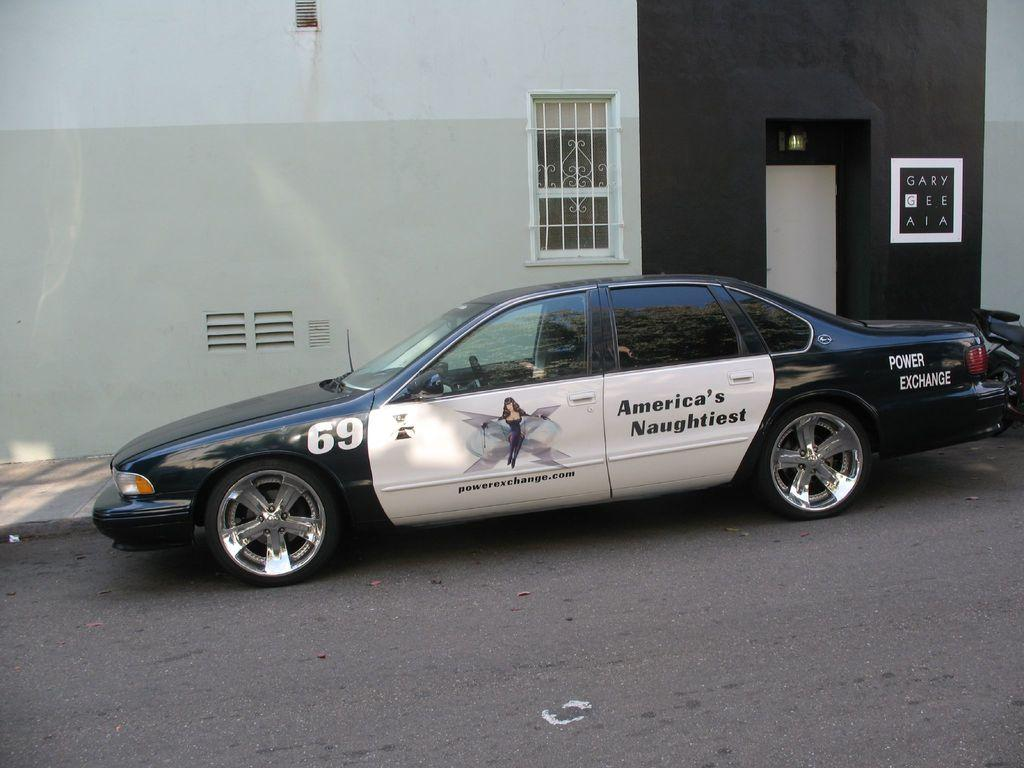What is the main subject of the image? The main subject of the image is a car. Where is the car located in the image? The car is on the road in the image. What can be seen in the background of the image? There is a building in the background of the image. How many frogs are jumping across the road in the image? There are no frogs present in the image; it features a car on the road with a building in the background. 